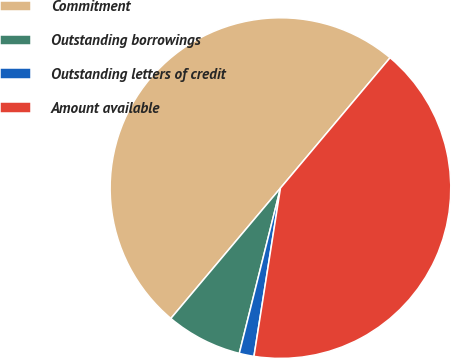Convert chart to OTSL. <chart><loc_0><loc_0><loc_500><loc_500><pie_chart><fcel>Commitment<fcel>Outstanding borrowings<fcel>Outstanding letters of credit<fcel>Amount available<nl><fcel>50.0%<fcel>7.24%<fcel>1.4%<fcel>41.36%<nl></chart> 